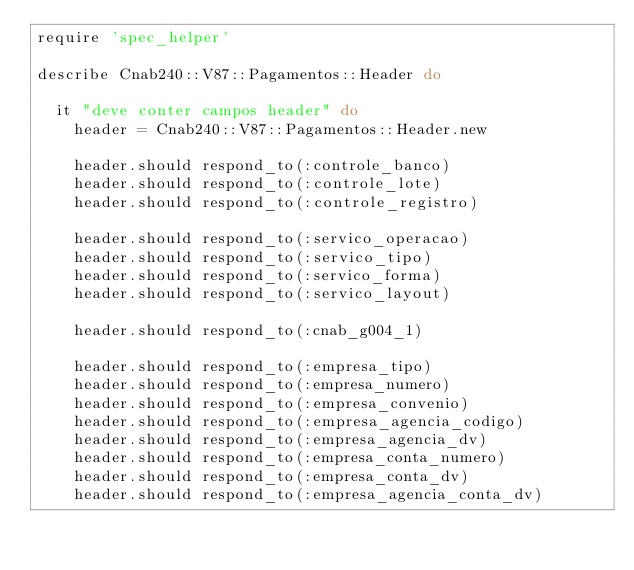Convert code to text. <code><loc_0><loc_0><loc_500><loc_500><_Ruby_>require 'spec_helper'

describe Cnab240::V87::Pagamentos::Header do

  it "deve conter campos header" do
    header = Cnab240::V87::Pagamentos::Header.new

    header.should respond_to(:controle_banco)
    header.should respond_to(:controle_lote)
    header.should respond_to(:controle_registro)

    header.should respond_to(:servico_operacao)
    header.should respond_to(:servico_tipo)
    header.should respond_to(:servico_forma)
    header.should respond_to(:servico_layout)

    header.should respond_to(:cnab_g004_1)

    header.should respond_to(:empresa_tipo)
    header.should respond_to(:empresa_numero)
    header.should respond_to(:empresa_convenio)
    header.should respond_to(:empresa_agencia_codigo)
    header.should respond_to(:empresa_agencia_dv)
    header.should respond_to(:empresa_conta_numero)
    header.should respond_to(:empresa_conta_dv)
    header.should respond_to(:empresa_agencia_conta_dv)</code> 